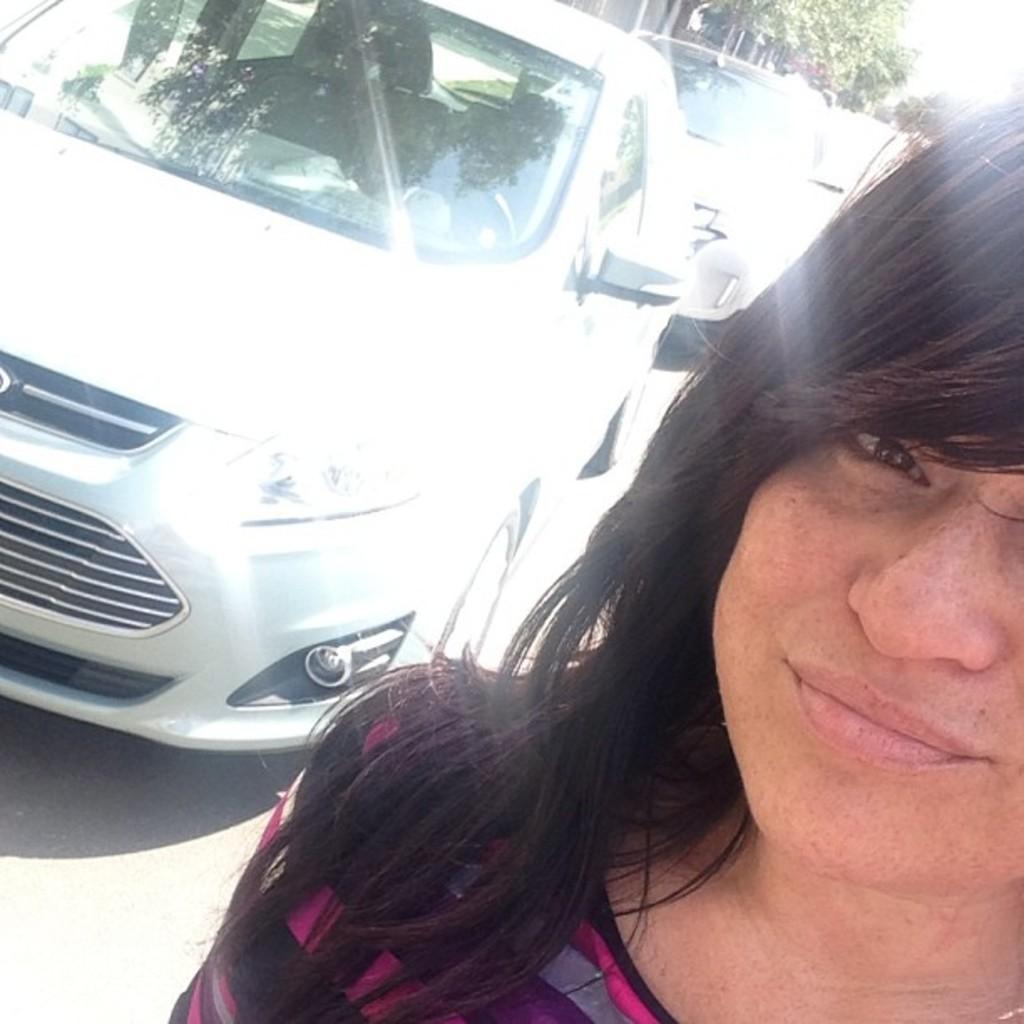Can you describe this image briefly? In this image, on the right side I can see a person and on the left side I can see some vehicles on the road, and at the top right hand side I can see some trees. 